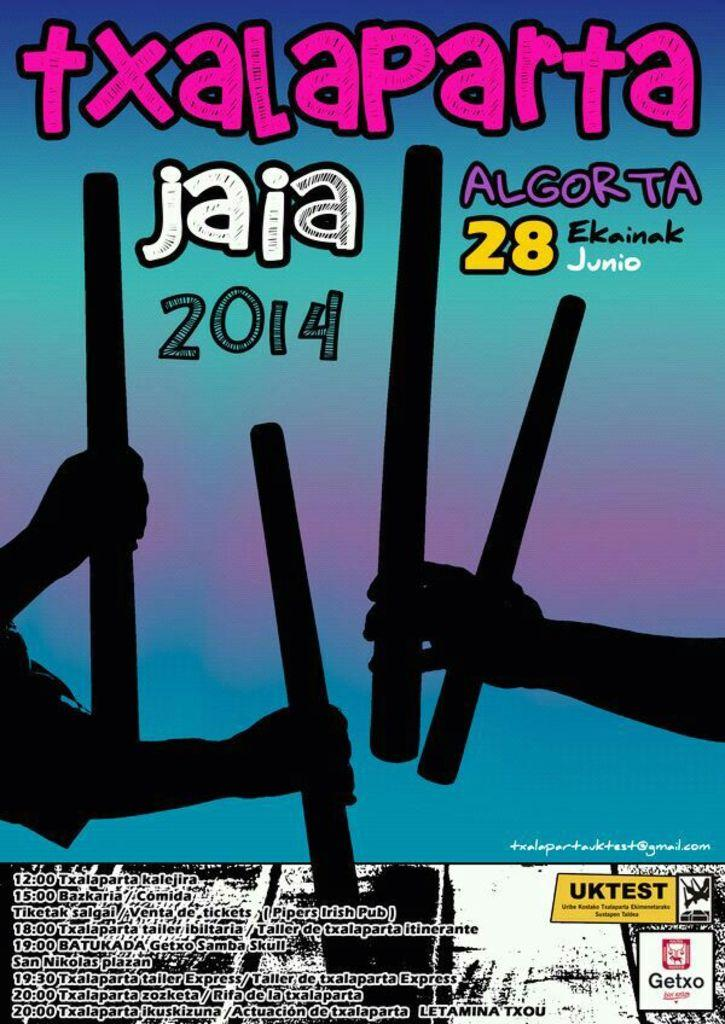<image>
Describe the image concisely. A poster for txalaparta on June 28 is on display. 